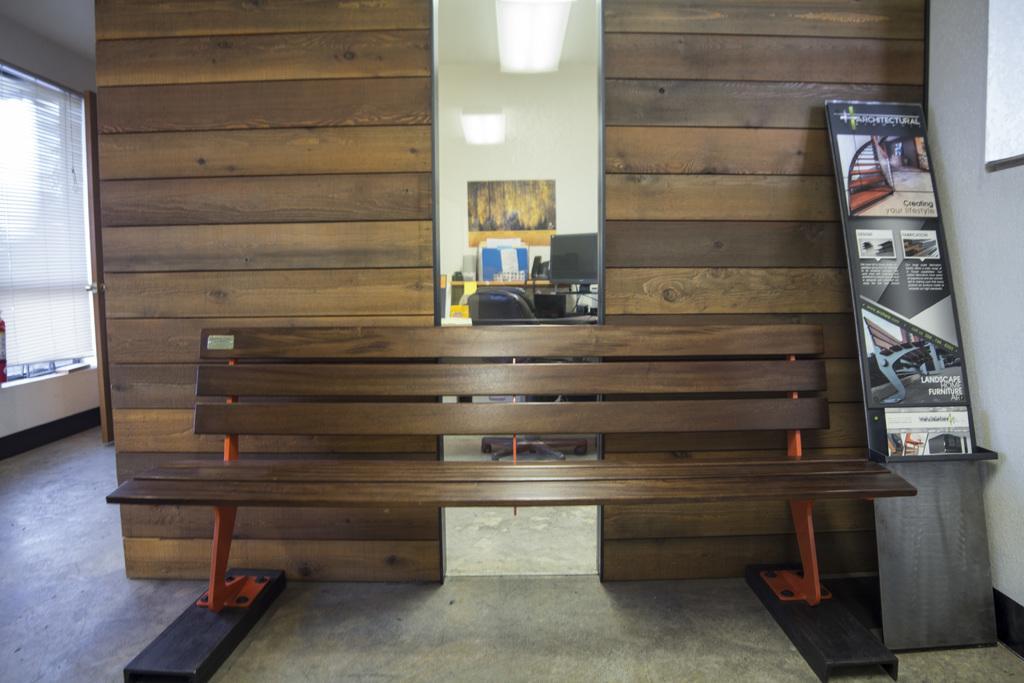Could you give a brief overview of what you see in this image? In this picture we can see a bench on the floor, posters, lights, walls, monitor, chair, some objects and in the background we can see a door, curtain. 